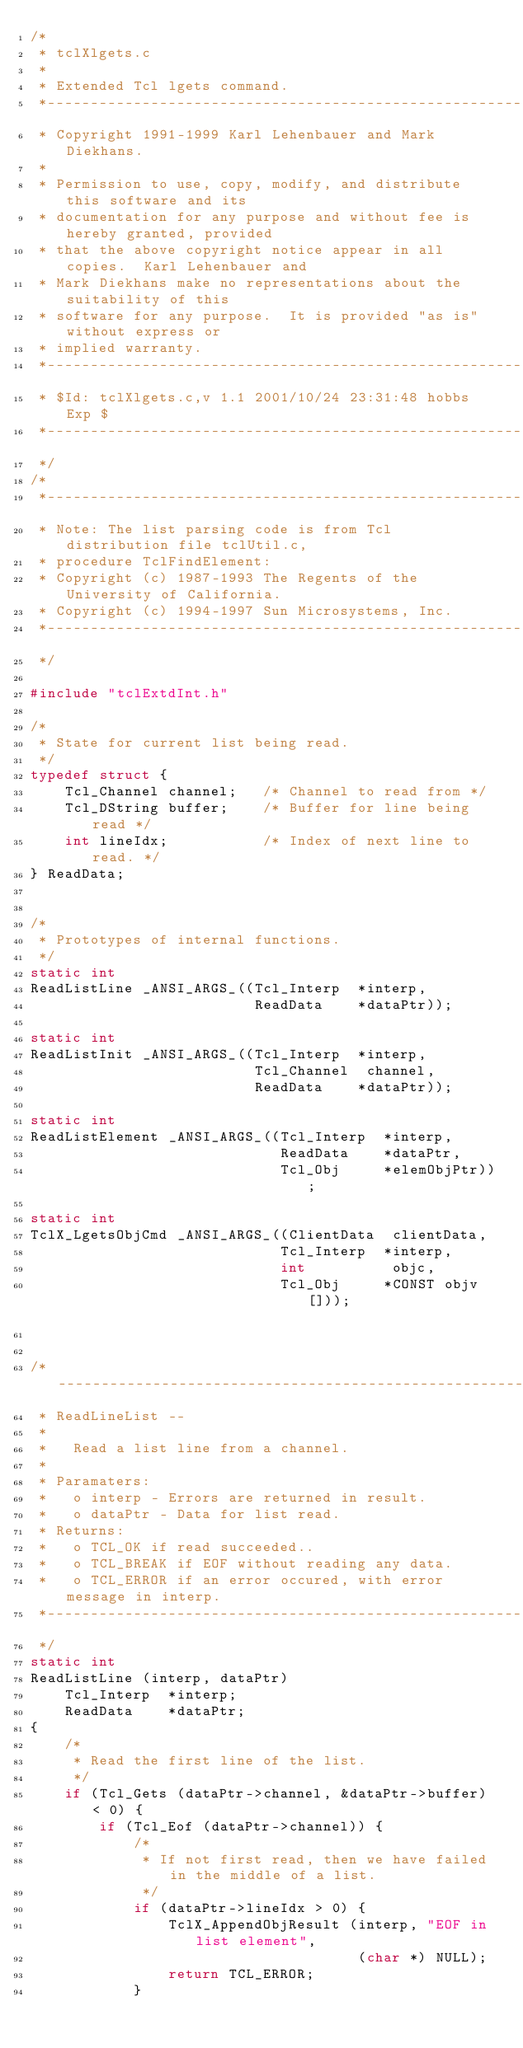Convert code to text. <code><loc_0><loc_0><loc_500><loc_500><_C_>/*
 * tclXlgets.c
 *
 * Extended Tcl lgets command.
 *-----------------------------------------------------------------------------
 * Copyright 1991-1999 Karl Lehenbauer and Mark Diekhans.
 *
 * Permission to use, copy, modify, and distribute this software and its
 * documentation for any purpose and without fee is hereby granted, provided
 * that the above copyright notice appear in all copies.  Karl Lehenbauer and
 * Mark Diekhans make no representations about the suitability of this
 * software for any purpose.  It is provided "as is" without express or
 * implied warranty.
 *-----------------------------------------------------------------------------
 * $Id: tclXlgets.c,v 1.1 2001/10/24 23:31:48 hobbs Exp $
 *-----------------------------------------------------------------------------
 */
/* 
 *-----------------------------------------------------------------------------
 * Note: The list parsing code is from Tcl distribution file tclUtil.c,
 * procedure TclFindElement:
 * Copyright (c) 1987-1993 The Regents of the University of California.
 * Copyright (c) 1994-1997 Sun Microsystems, Inc.
 *-----------------------------------------------------------------------------
 */

#include "tclExtdInt.h"

/*
 * State for current list being read.
 */
typedef struct {
    Tcl_Channel channel;   /* Channel to read from */
    Tcl_DString buffer;    /* Buffer for line being read */
    int lineIdx;           /* Index of next line to read. */
} ReadData;


/*
 * Prototypes of internal functions.
 */
static int
ReadListLine _ANSI_ARGS_((Tcl_Interp  *interp,
                          ReadData    *dataPtr));

static int
ReadListInit _ANSI_ARGS_((Tcl_Interp  *interp,
                          Tcl_Channel  channel,
                          ReadData    *dataPtr));

static int
ReadListElement _ANSI_ARGS_((Tcl_Interp  *interp,
                             ReadData    *dataPtr,
                             Tcl_Obj     *elemObjPtr));

static int 
TclX_LgetsObjCmd _ANSI_ARGS_((ClientData  clientData, 
                             Tcl_Interp  *interp, 
                             int          objc,
                             Tcl_Obj     *CONST objv[]));


/*-----------------------------------------------------------------------------
 * ReadLineList --
 *
 *   Read a list line from a channel.
 *
 * Paramaters:
 *   o interp - Errors are returned in result.
 *   o dataPtr - Data for list read.
 * Returns:
 *   o TCL_OK if read succeeded..
 *   o TCL_BREAK if EOF without reading any data.
 *   o TCL_ERROR if an error occured, with error message in interp.
 *-----------------------------------------------------------------------------
 */
static int
ReadListLine (interp, dataPtr)
    Tcl_Interp  *interp;
    ReadData    *dataPtr;
{
    /*
     * Read the first line of the list. 
     */
    if (Tcl_Gets (dataPtr->channel, &dataPtr->buffer) < 0) {
        if (Tcl_Eof (dataPtr->channel)) {
            /*
             * If not first read, then we have failed in the middle of a list.
             */
            if (dataPtr->lineIdx > 0) {
                TclX_AppendObjResult (interp, "EOF in list element",
                                      (char *) NULL);
                return TCL_ERROR;
            }</code> 